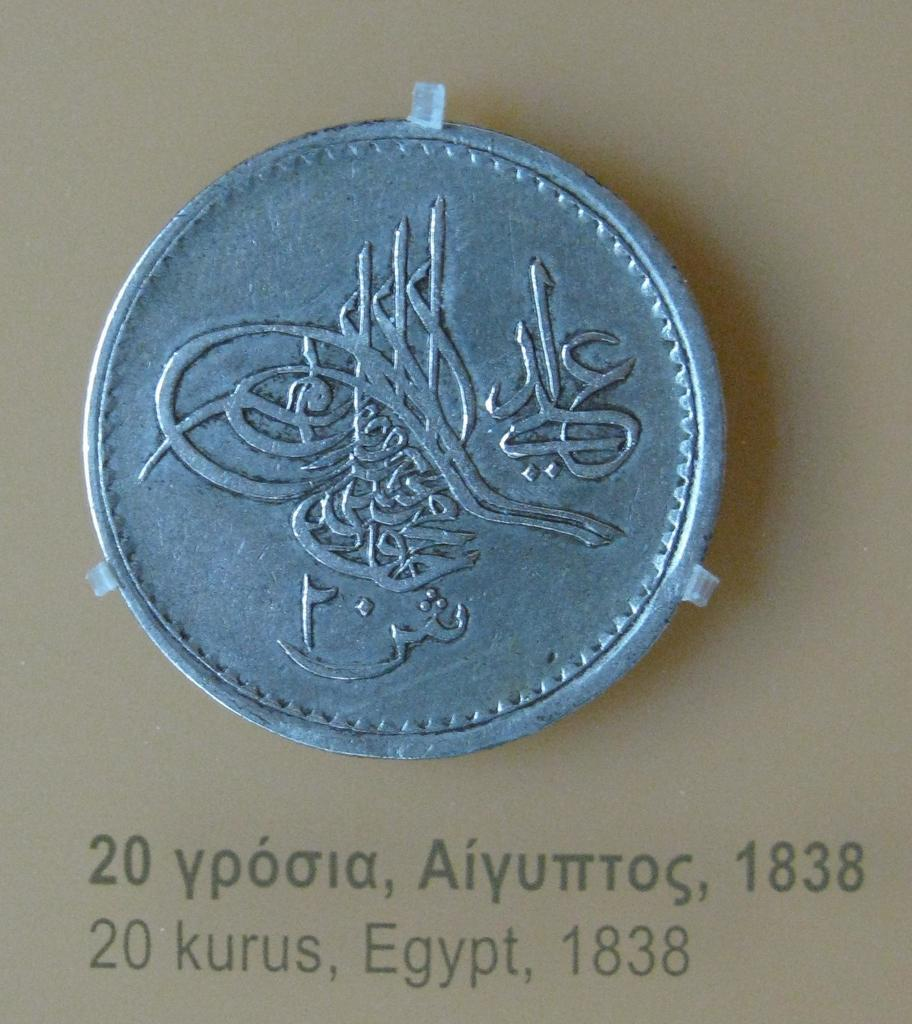Provide a one-sentence caption for the provided image. An Egyptian twenty Kuru coin minted in 1838. 